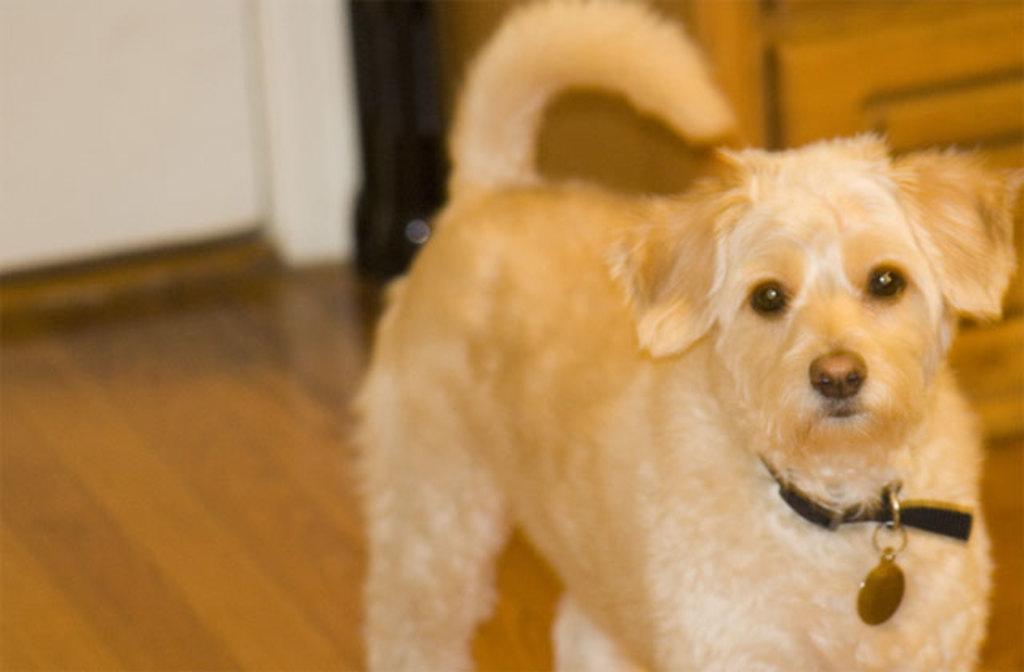Please provide a concise description of this image. In the center of the image there is a dog on the floor. In the background there is a door and wall. 